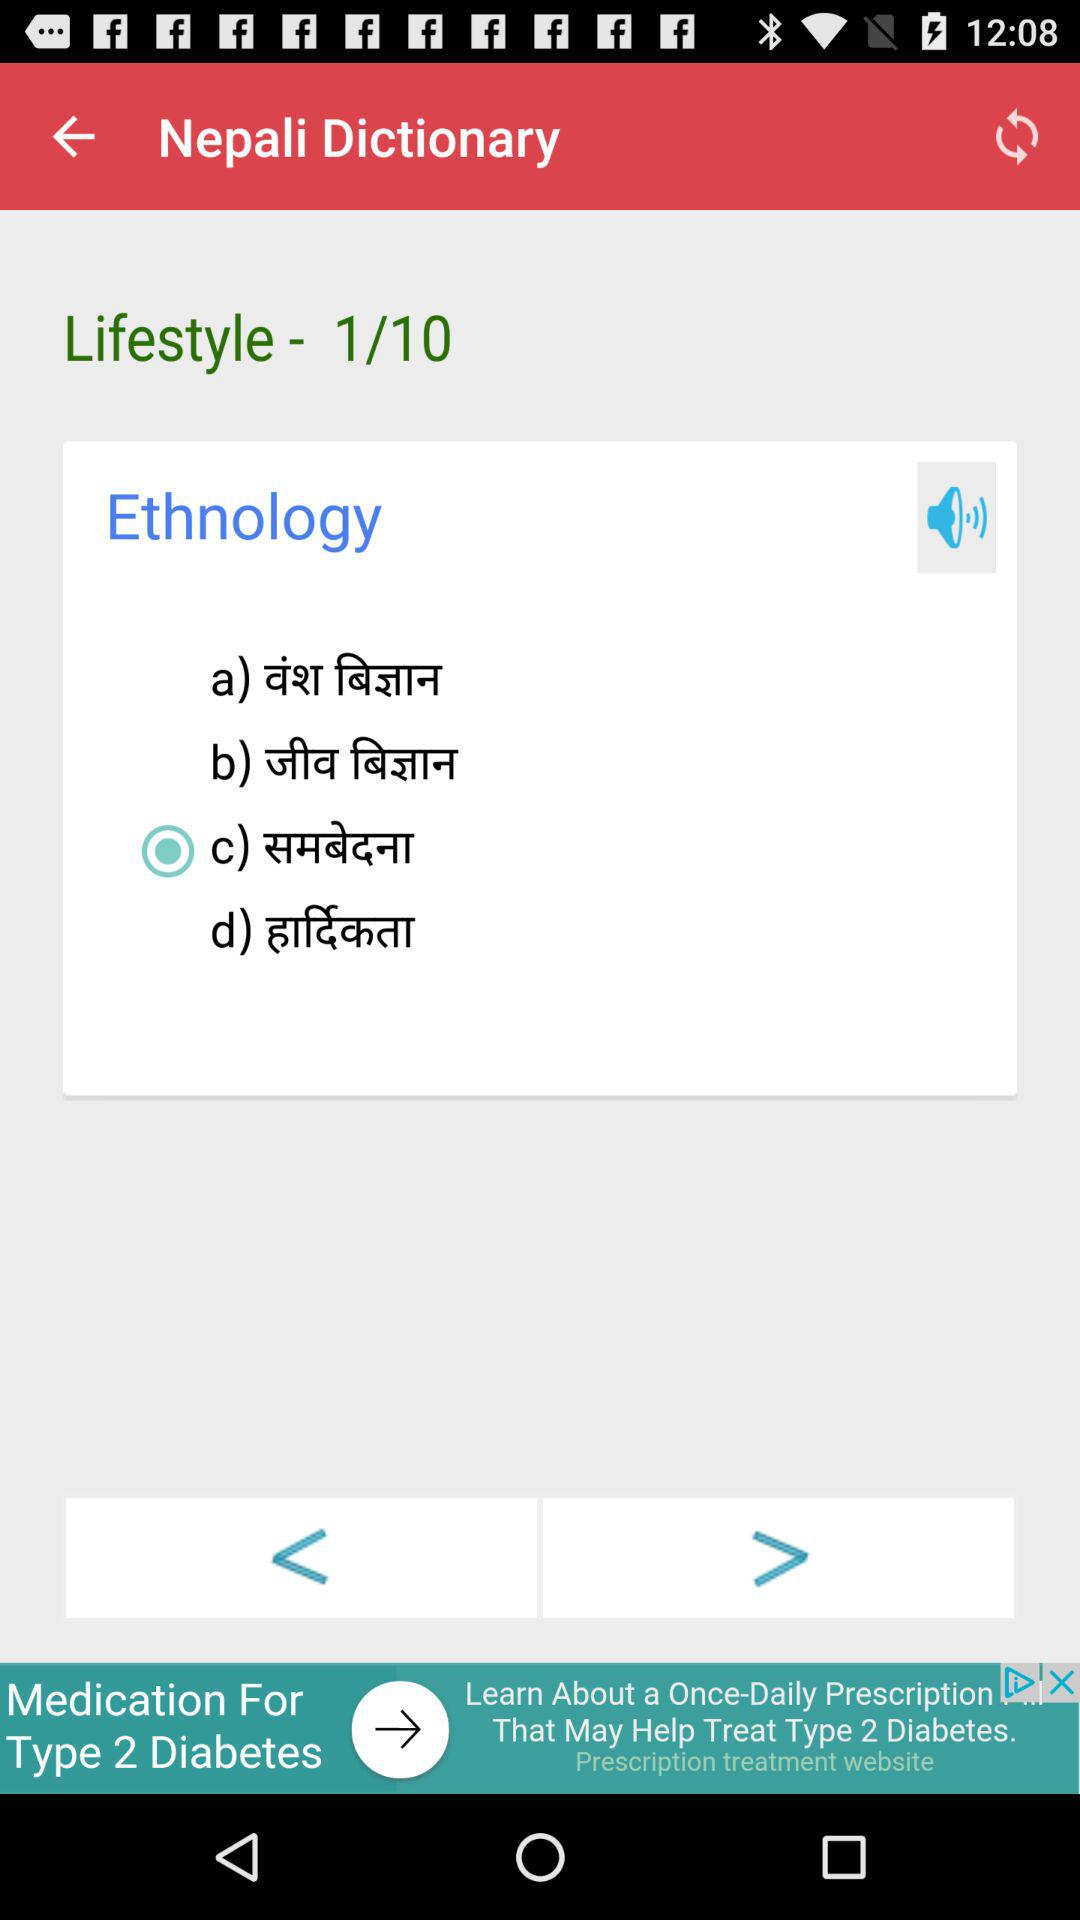What is the total number of questions in lifestyle? The total number of questions is 10. 